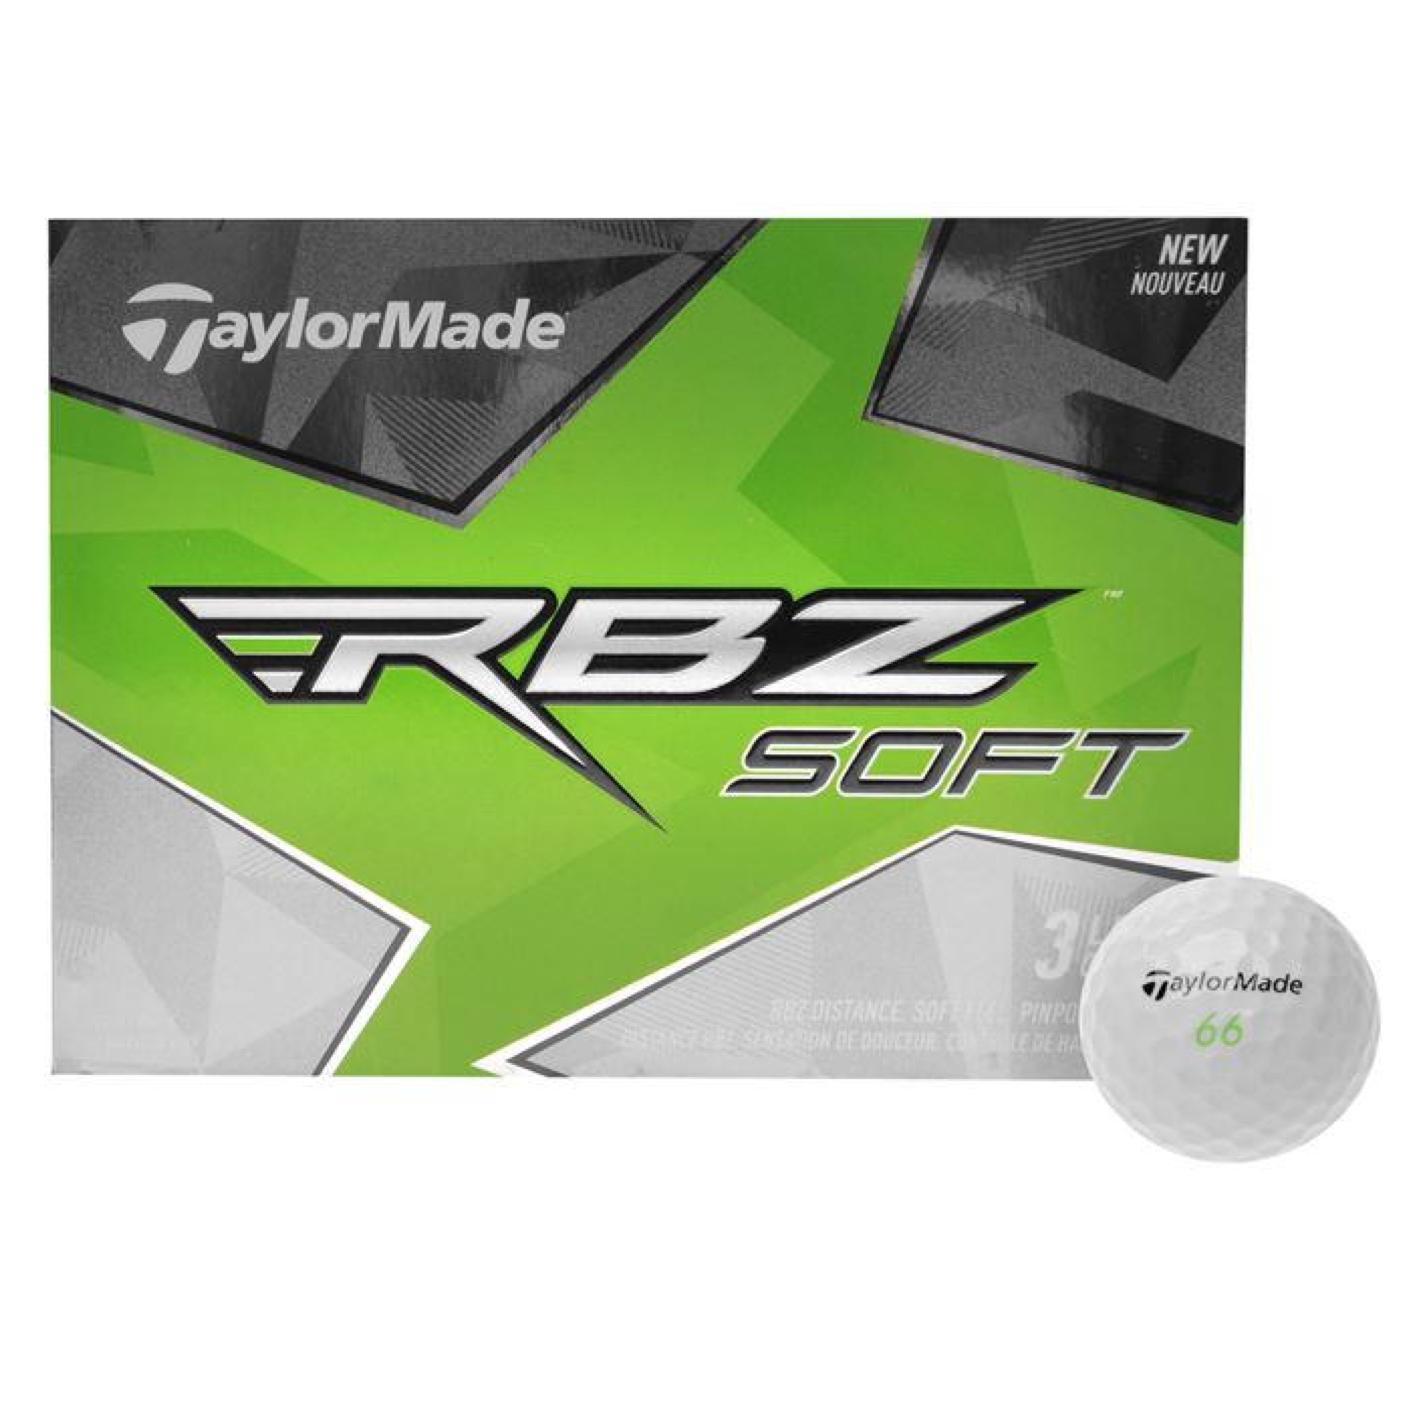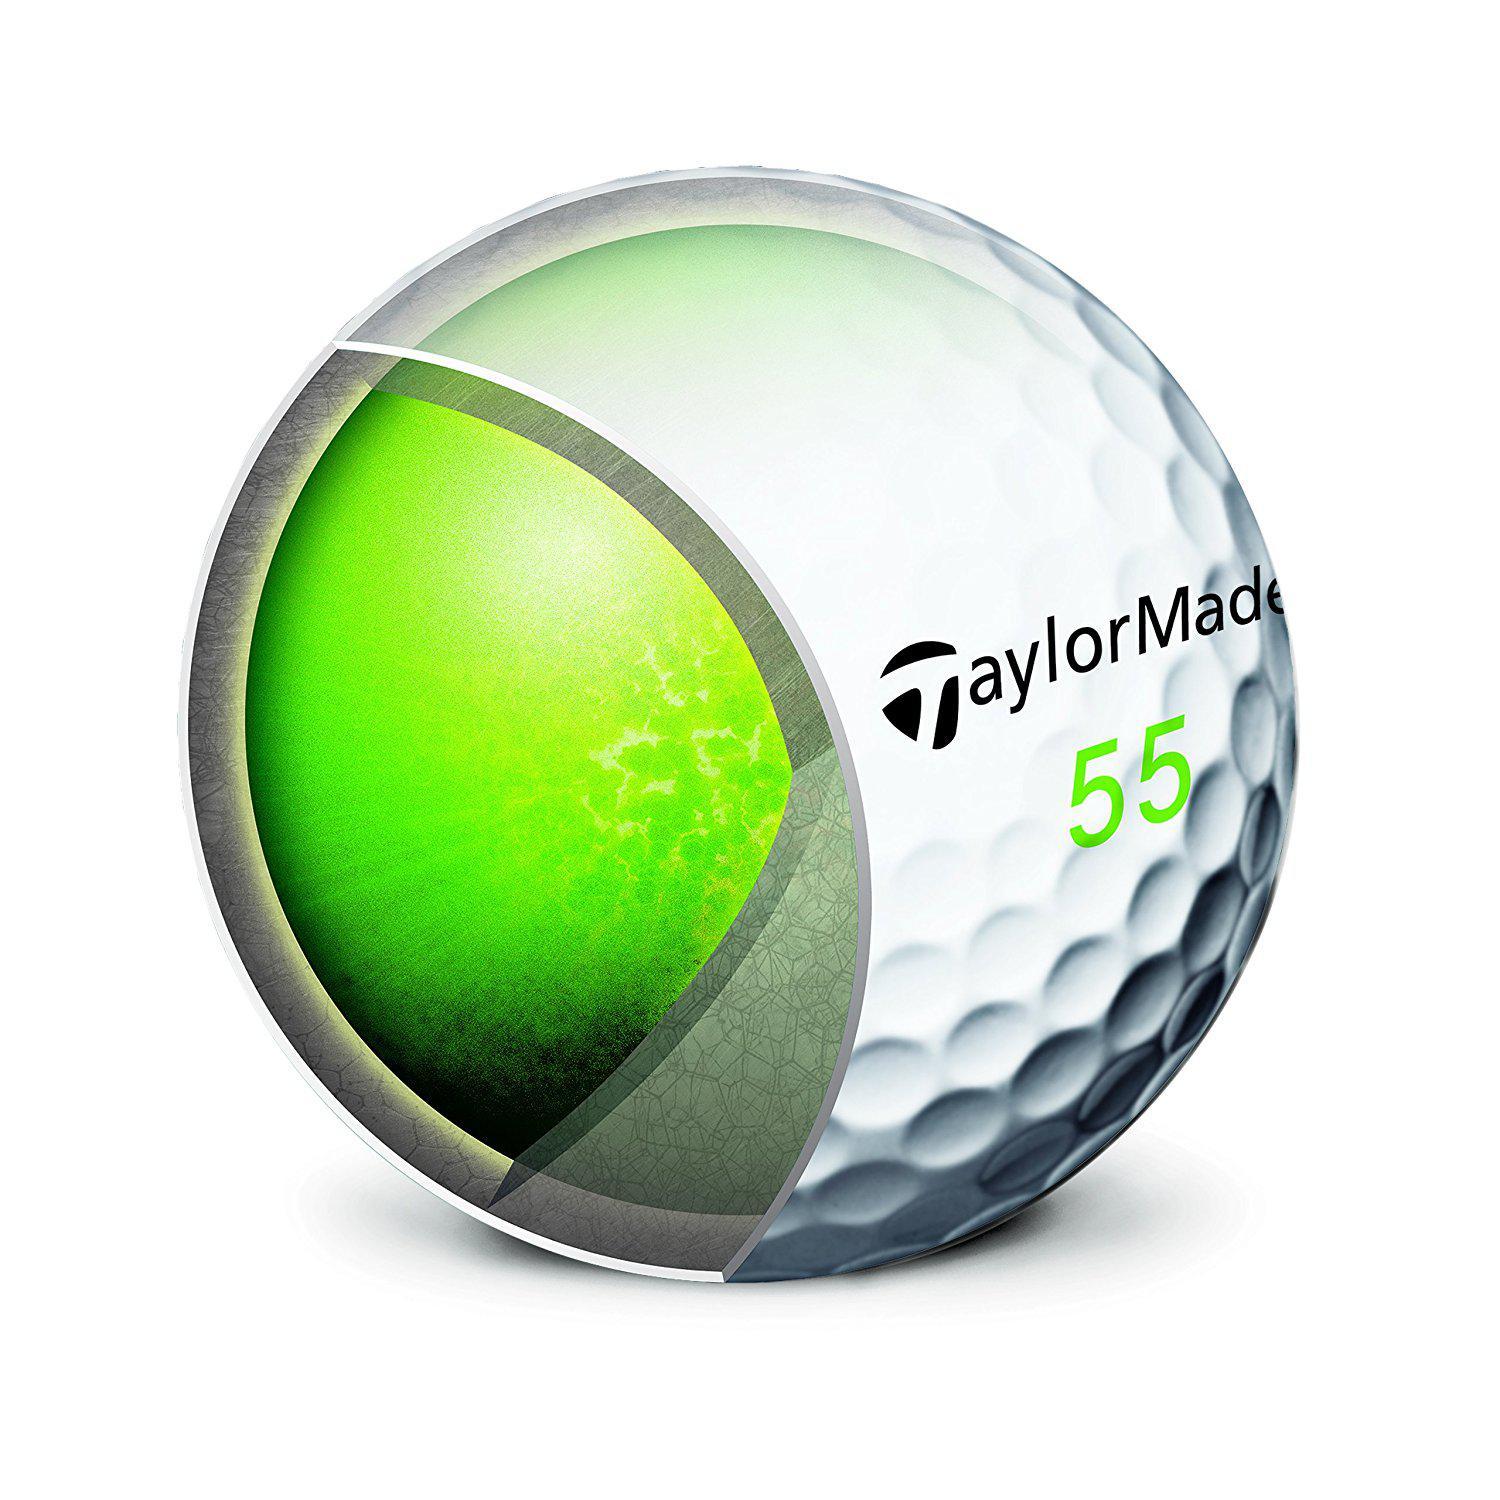The first image is the image on the left, the second image is the image on the right. Given the left and right images, does the statement "The left image shows a box with """"RBZ SOFT"""" shown on it." hold true? Answer yes or no. Yes. 